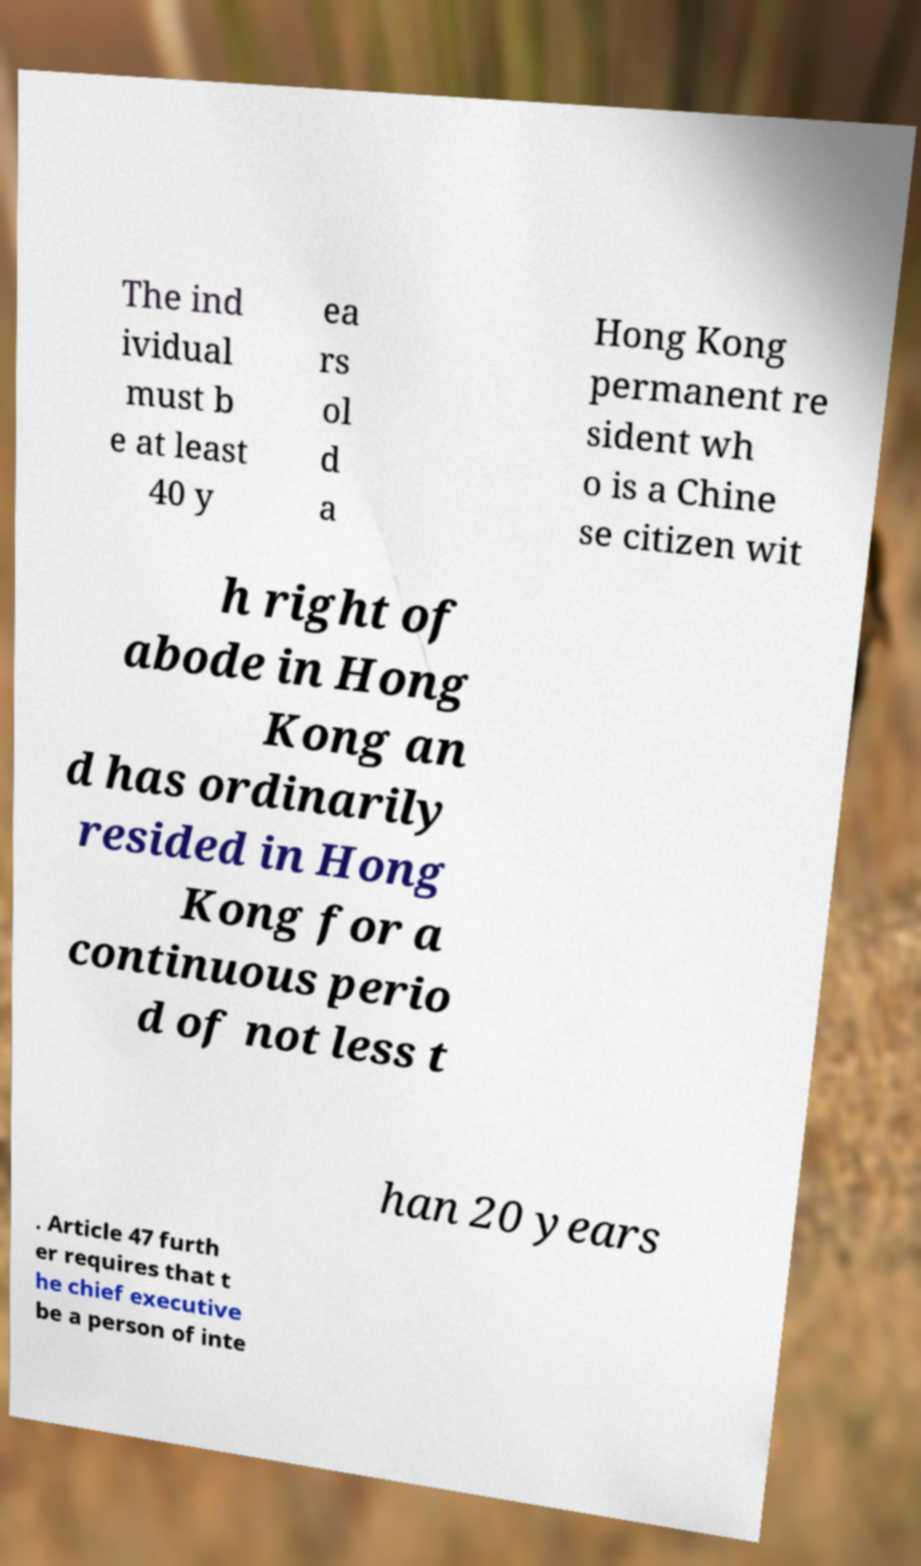Could you assist in decoding the text presented in this image and type it out clearly? The ind ividual must b e at least 40 y ea rs ol d a Hong Kong permanent re sident wh o is a Chine se citizen wit h right of abode in Hong Kong an d has ordinarily resided in Hong Kong for a continuous perio d of not less t han 20 years . Article 47 furth er requires that t he chief executive be a person of inte 